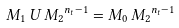Convert formula to latex. <formula><loc_0><loc_0><loc_500><loc_500>M _ { 1 } \, U \, { M _ { 2 } } ^ { n _ { t } - 1 } = M _ { 0 } \, { M _ { 2 } } ^ { n _ { t } - 1 }</formula> 